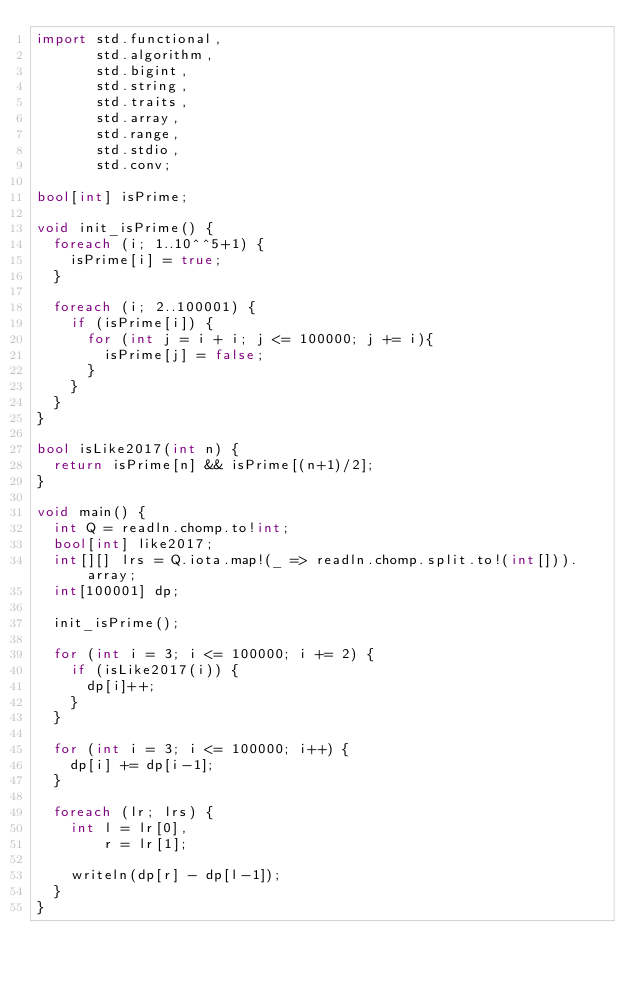<code> <loc_0><loc_0><loc_500><loc_500><_D_>import std.functional,
       std.algorithm,
       std.bigint,
       std.string,
       std.traits,
       std.array,
       std.range,
       std.stdio,
       std.conv;

bool[int] isPrime;

void init_isPrime() {
  foreach (i; 1..10^^5+1) {
    isPrime[i] = true;
  }

  foreach (i; 2..100001) {
    if (isPrime[i]) {
      for (int j = i + i; j <= 100000; j += i){
        isPrime[j] = false;
      }
    }
  }
}

bool isLike2017(int n) {
  return isPrime[n] && isPrime[(n+1)/2];
}

void main() {
  int Q = readln.chomp.to!int;
  bool[int] like2017;
  int[][] lrs = Q.iota.map!(_ => readln.chomp.split.to!(int[])).array;
  int[100001] dp;
  
  init_isPrime();

  for (int i = 3; i <= 100000; i += 2) {
    if (isLike2017(i)) {
      dp[i]++;
    }
  }

  for (int i = 3; i <= 100000; i++) {
    dp[i] += dp[i-1];
  }

  foreach (lr; lrs) {
    int l = lr[0],
        r = lr[1];

    writeln(dp[r] - dp[l-1]);
  }
}
</code> 